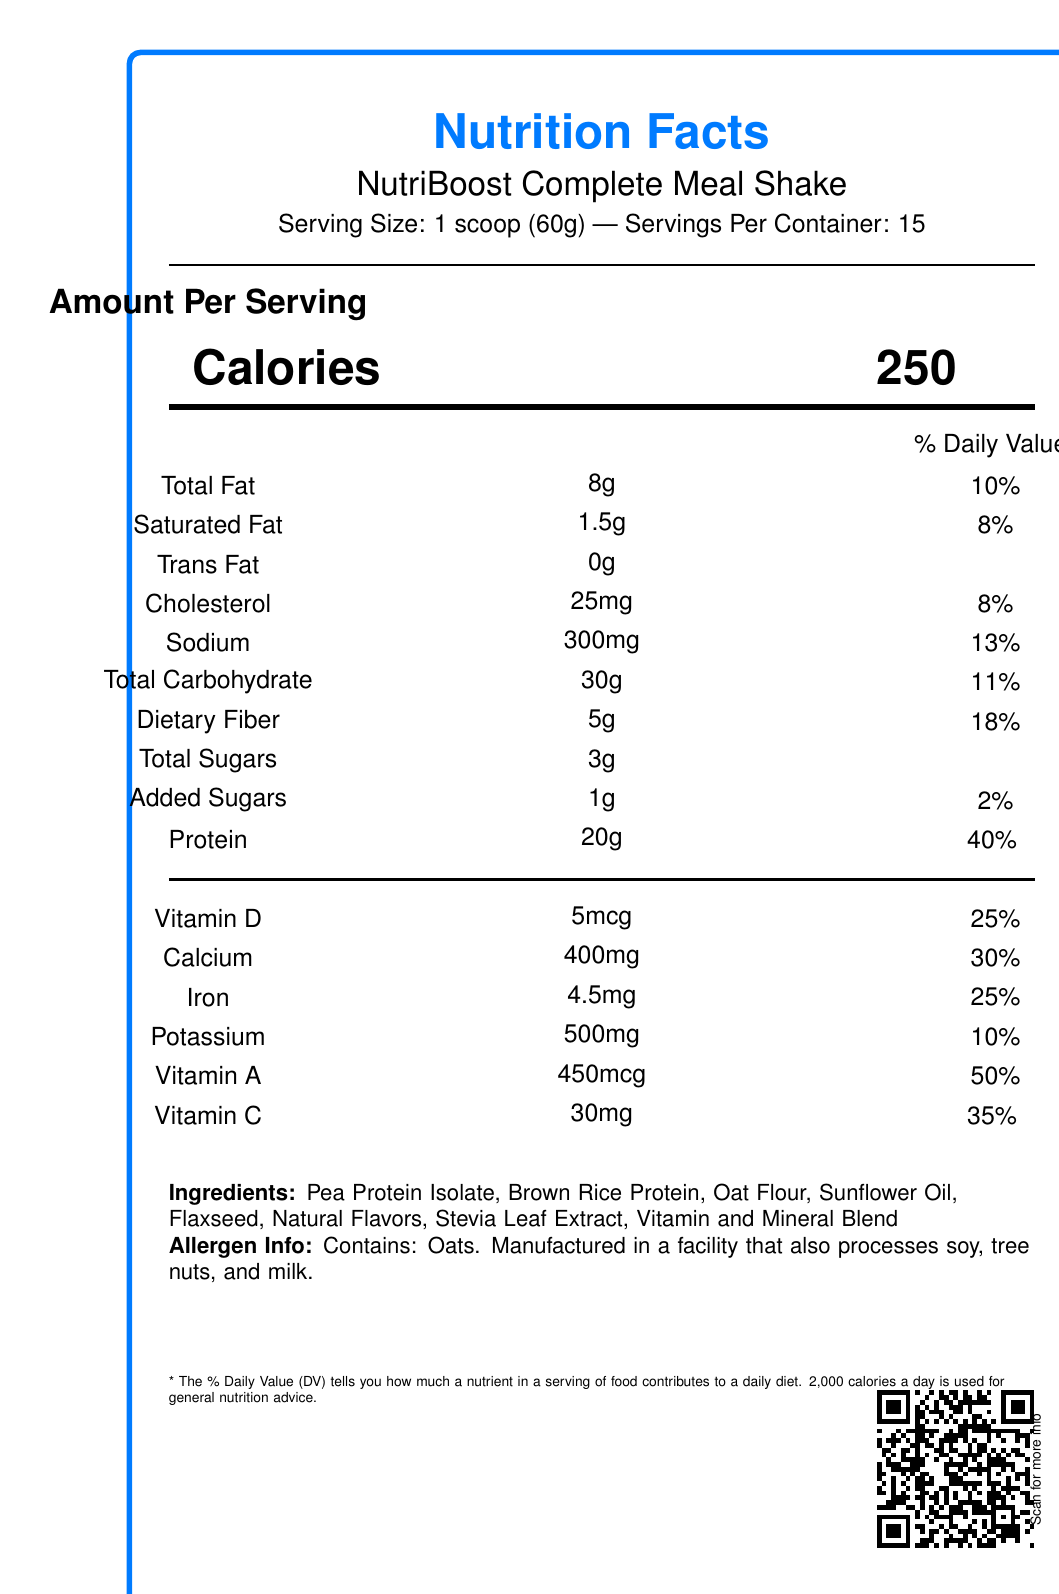What is the serving size of NutriBoost Complete Meal Shake? The serving size is mentioned near the top of the label indicating "Serving Size: 1 scoop (60g)".
Answer: 1 scoop (60g) How many calories are there per serving? The calories per serving are listed right under the heading "Amount Per Serving" showing "Calories 250".
Answer: 250 What percentage of daily value of dietary fiber does one serving contain? The daily value percentage for dietary fiber is listed in the section with other nutritional values as "Dietary Fiber 5g 18%".
Answer: 18% How many servings are there in one container? The number of servings per container is stated at the top: "Servings Per Container: 15".
Answer: 15 List three ingredients found in NutriBoost Complete Meal Shake. These are the first three ingredients listed under the ingredients section.
Answer: Pea Protein Isolate, Brown Rice Protein, Oat Flour Which nutrient has the highest percentage of the daily value per serving?    A. Protein B. Calcium C. Potassium D. Vitamin A Vitamin A has a daily value of 50%, which is the highest mentioned on the label.
Answer: D Which of the following options is not present in the NutriBoost Complete Meal Shake nutrition label?    I. Vitamin D II. Vitamin B12 III. Iron IV. Vitamin C Vitamin B12 is not listed in the provided nutrition facts.
Answer: II Does the NutriBoost Complete Meal Shake contain any added sugars? The label indicates that it contains "Added Sugars 1g 2%".
Answer: Yes How is the interactive QR code positioned on the label? The QR code data specifies its position as "bottom-right".
Answer: Bottom-right Summarize the main features of the NutriBoost Complete Meal Shake nutrition label. The summary captures the overview of nutritional contents, interactive elements, and accessibility features included in the label.
Answer: The NutriBoost Complete Meal Shake nutrition label provides detailed information about the contents and nutritional values per serving of the shake. It lists calories, macronutrients, vitamins, and minerals, along with ingredients and allergen information. The label includes interactive elements such as a QR code for additional information and tooltips for nutrients. Accessibility features like high contrast text and screen reader compatibility are also incorporated. What benefits does vitamin D provide? The document provides information that there is an interactive element (hover) that shows a tooltip with vitamin D benefits, but the actual benefits are not mentioned in the visual document.
Answer: Not enough information 